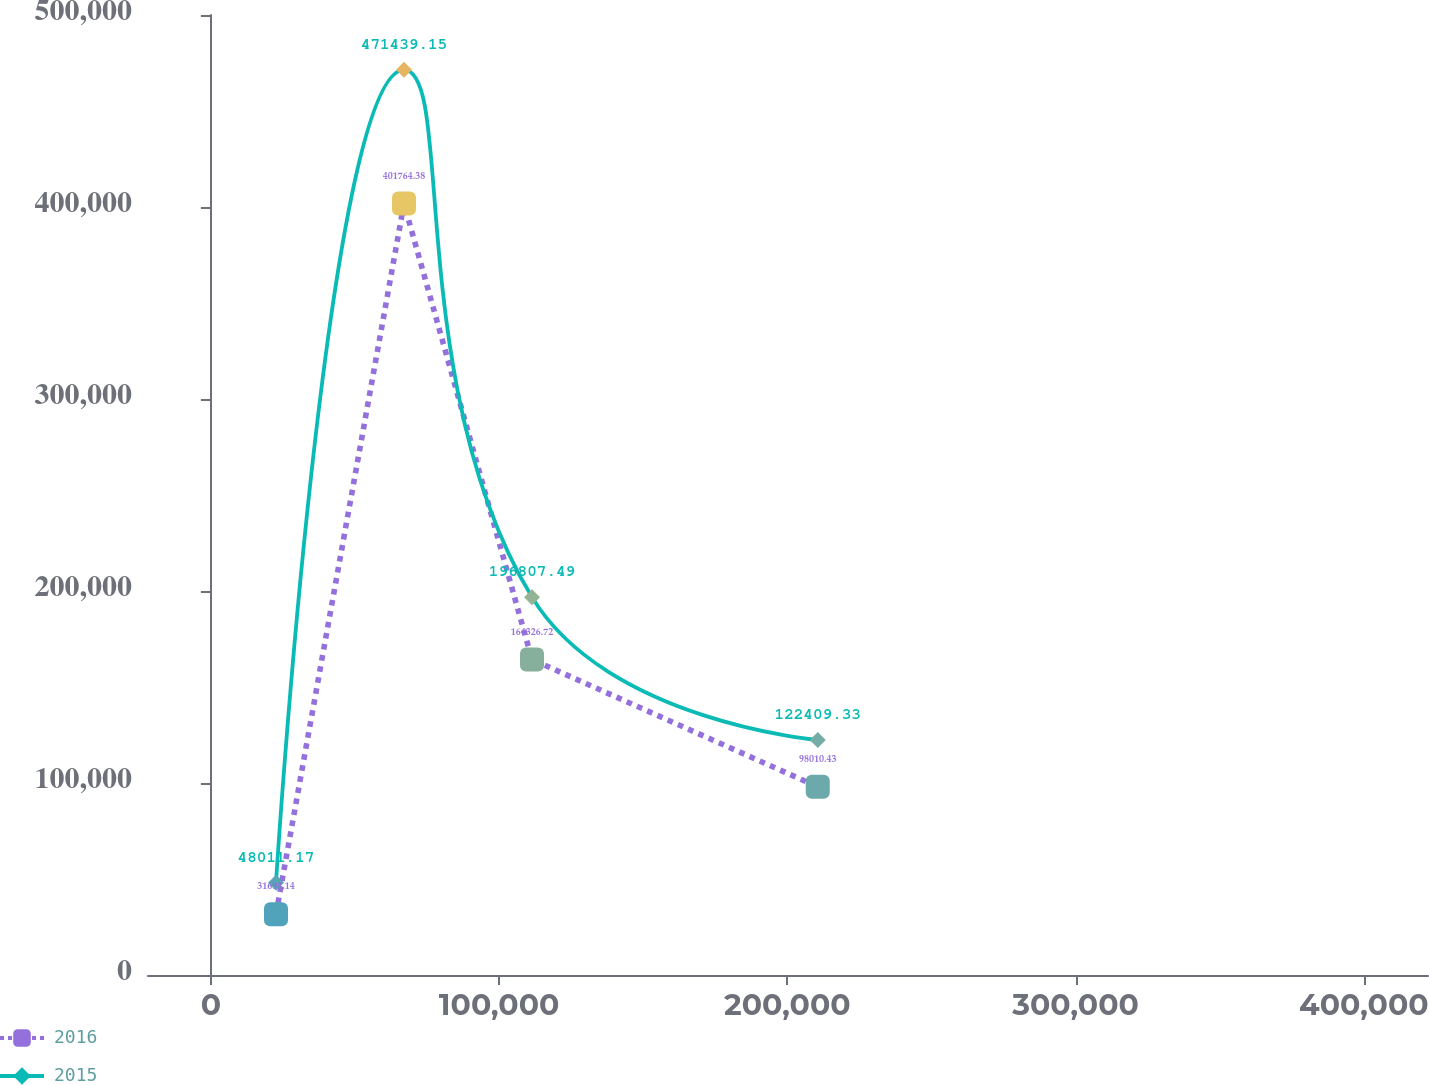<chart> <loc_0><loc_0><loc_500><loc_500><line_chart><ecel><fcel>2016<fcel>2015<nl><fcel>22599.9<fcel>31694.1<fcel>48011.2<nl><fcel>67006.8<fcel>401764<fcel>471439<nl><fcel>111414<fcel>164327<fcel>196807<nl><fcel>210548<fcel>98010.4<fcel>122409<nl><fcel>466669<fcel>694857<fcel>791993<nl></chart> 